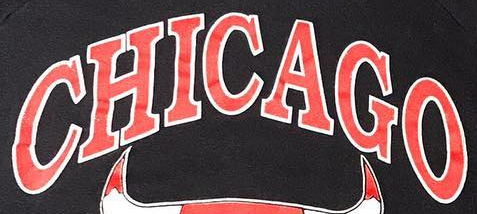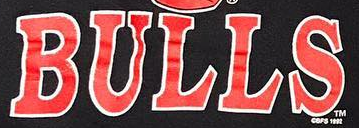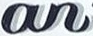What text appears in these images from left to right, separated by a semicolon? CHICAGO; BULLS; an 